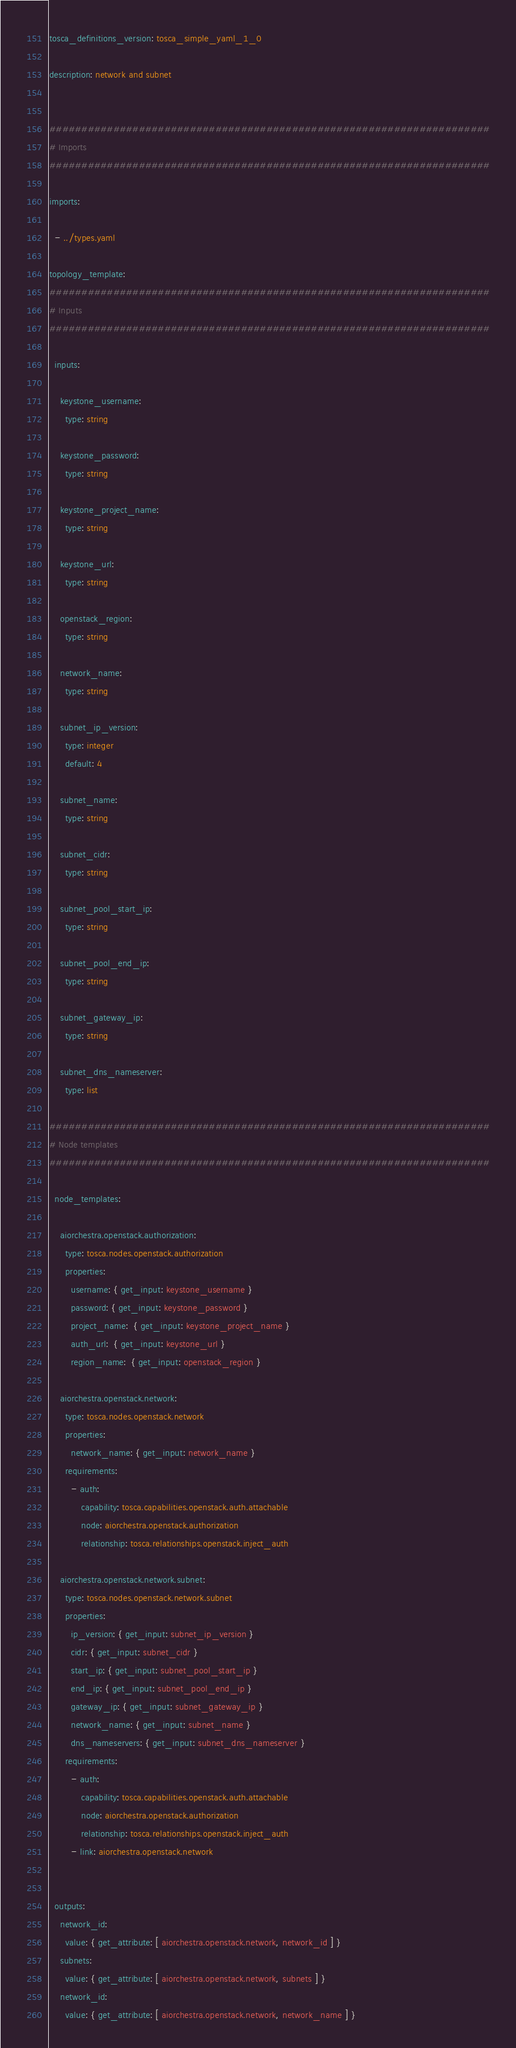Convert code to text. <code><loc_0><loc_0><loc_500><loc_500><_YAML_>tosca_definitions_version: tosca_simple_yaml_1_0

description: network and subnet


#####################################################################
# Imports
#####################################################################

imports:

  - ../types.yaml

topology_template:
#####################################################################
# Inputs
#####################################################################

  inputs:

    keystone_username:
      type: string

    keystone_password:
      type: string

    keystone_project_name:
      type: string

    keystone_url:
      type: string

    openstack_region:
      type: string

    network_name:
      type: string

    subnet_ip_version:
      type: integer
      default: 4

    subnet_name:
      type: string

    subnet_cidr:
      type: string

    subnet_pool_start_ip:
      type: string

    subnet_pool_end_ip:
      type: string

    subnet_gateway_ip:
      type: string

    subnet_dns_nameserver:
      type: list

#####################################################################
# Node templates
#####################################################################

  node_templates:

    aiorchestra.openstack.authorization:
      type: tosca.nodes.openstack.authorization
      properties:
        username: { get_input: keystone_username }
        password: { get_input: keystone_password }
        project_name:  { get_input: keystone_project_name }
        auth_url:  { get_input: keystone_url }
        region_name:  { get_input: openstack_region }

    aiorchestra.openstack.network:
      type: tosca.nodes.openstack.network
      properties:
        network_name: { get_input: network_name }
      requirements:
        - auth:
            capability: tosca.capabilities.openstack.auth.attachable
            node: aiorchestra.openstack.authorization
            relationship: tosca.relationships.openstack.inject_auth

    aiorchestra.openstack.network.subnet:
      type: tosca.nodes.openstack.network.subnet
      properties:
        ip_version: { get_input: subnet_ip_version }
        cidr: { get_input: subnet_cidr }
        start_ip: { get_input: subnet_pool_start_ip }
        end_ip: { get_input: subnet_pool_end_ip }
        gateway_ip: { get_input: subnet_gateway_ip }
        network_name: { get_input: subnet_name }
        dns_nameservers: { get_input: subnet_dns_nameserver }
      requirements:
        - auth:
            capability: tosca.capabilities.openstack.auth.attachable
            node: aiorchestra.openstack.authorization
            relationship: tosca.relationships.openstack.inject_auth
        - link: aiorchestra.openstack.network


  outputs:
    network_id:
      value: { get_attribute: [ aiorchestra.openstack.network, network_id ] }
    subnets:
      value: { get_attribute: [ aiorchestra.openstack.network, subnets ] }
    network_id:
      value: { get_attribute: [ aiorchestra.openstack.network, network_name ] }
</code> 